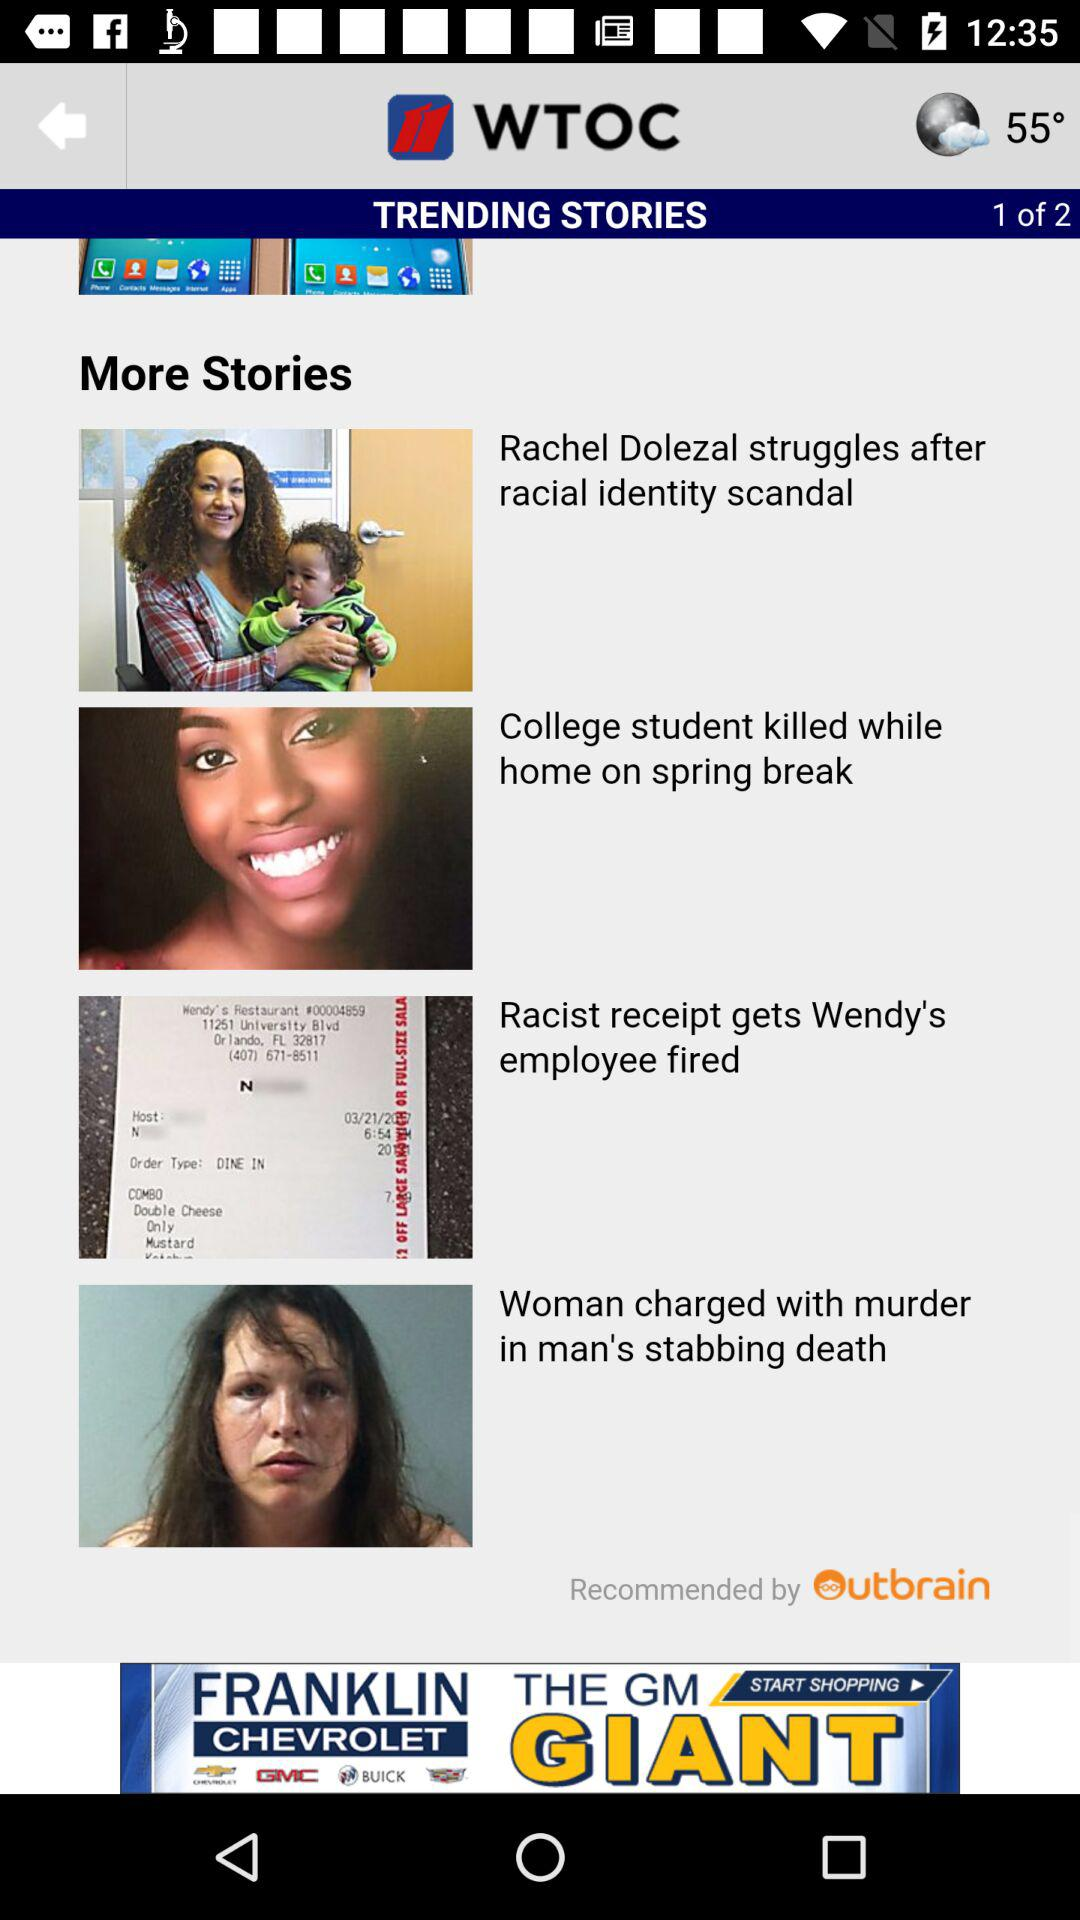How many pages are there in total? There are a total of 2 pages. 